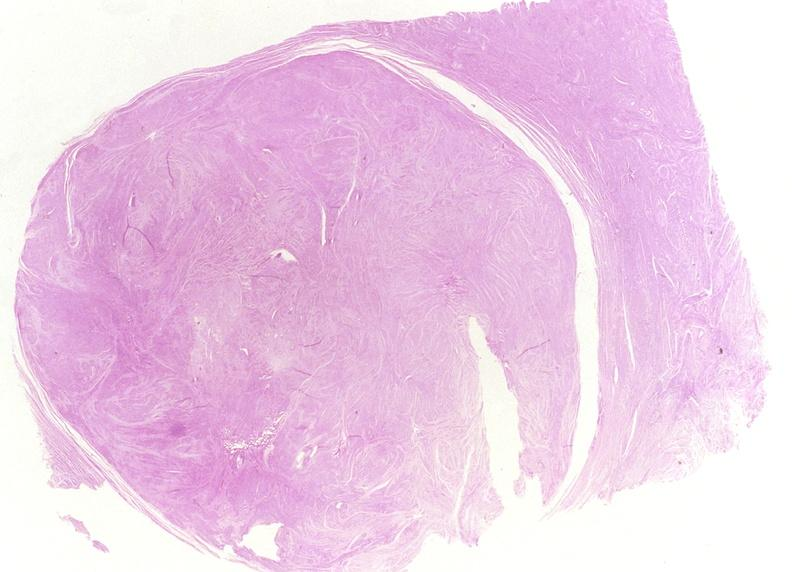s angiogram present?
Answer the question using a single word or phrase. No 